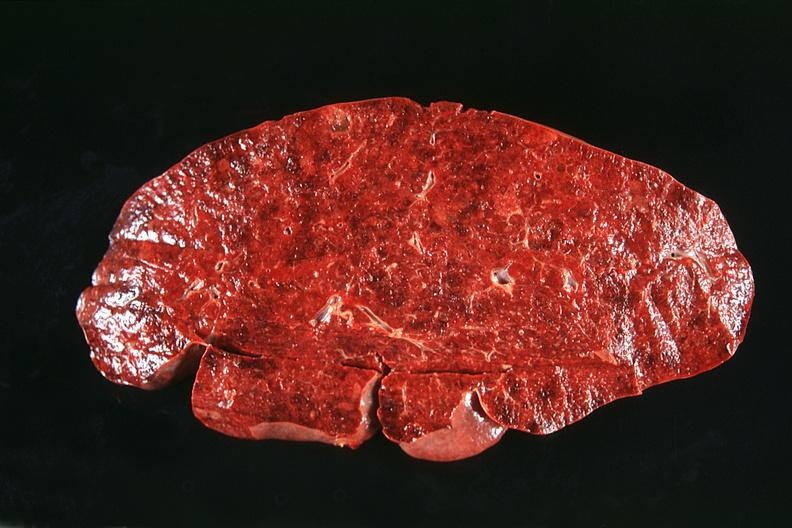s nodule present?
Answer the question using a single word or phrase. No 